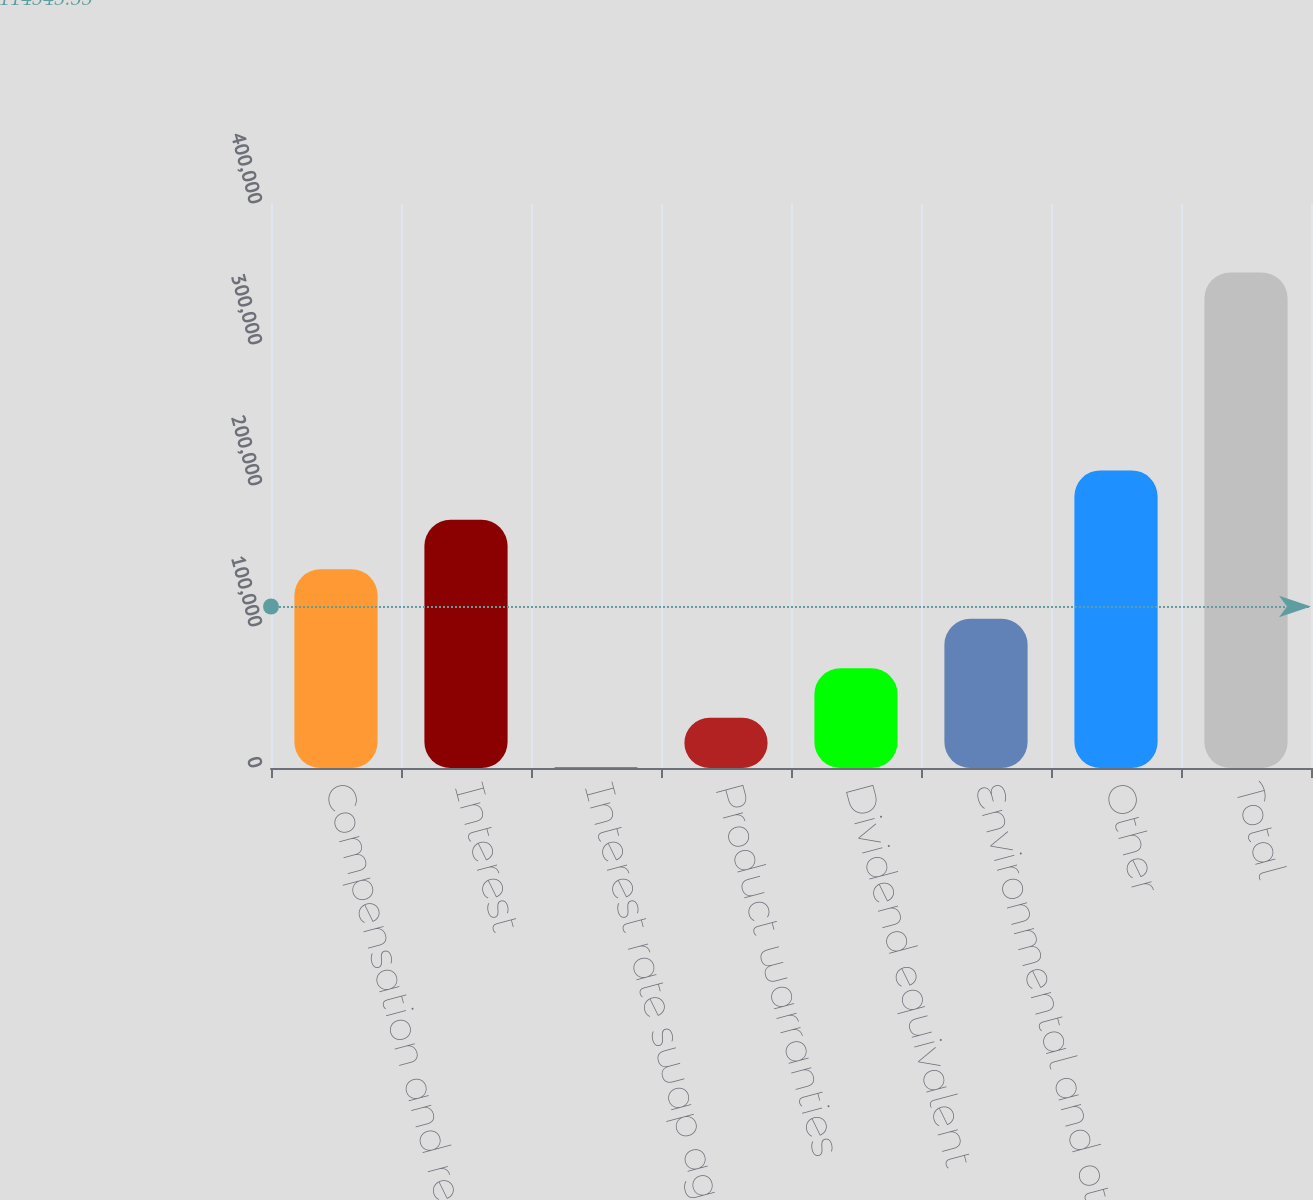Convert chart to OTSL. <chart><loc_0><loc_0><loc_500><loc_500><bar_chart><fcel>Compensation and related<fcel>Interest<fcel>Interest rate swap agreements<fcel>Product warranties<fcel>Dividend equivalent<fcel>Environmental and other<fcel>Other<fcel>Total<nl><fcel>140894<fcel>175986<fcel>528<fcel>35619.5<fcel>70711<fcel>105802<fcel>211077<fcel>351443<nl></chart> 